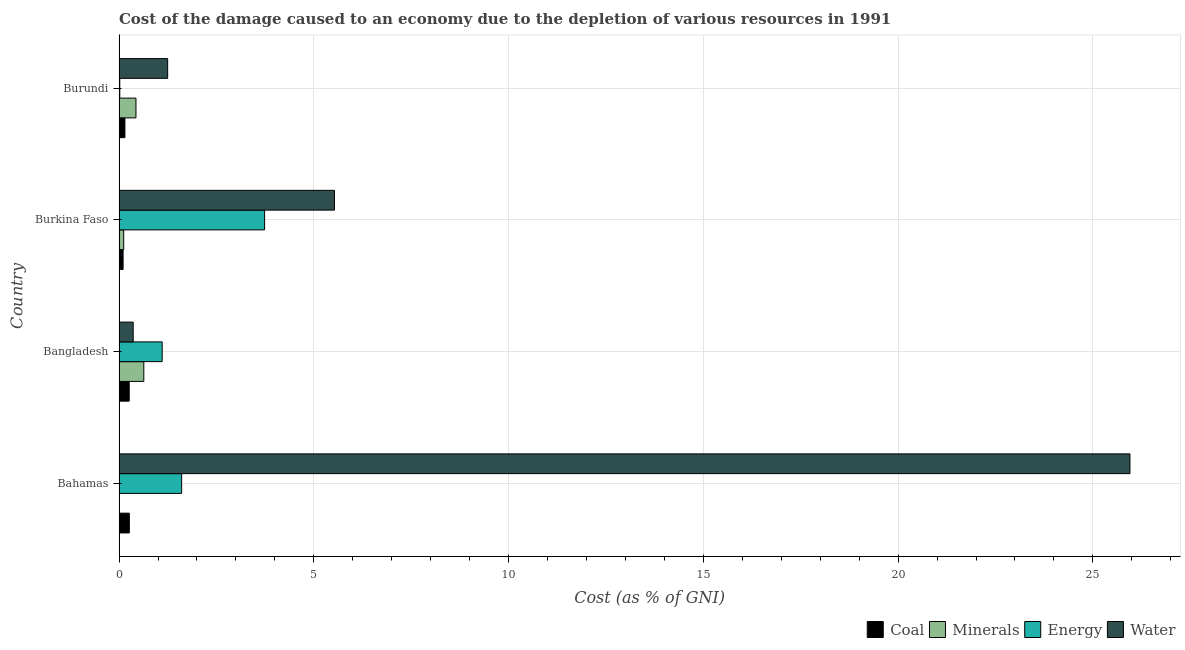How many groups of bars are there?
Your response must be concise. 4. Are the number of bars on each tick of the Y-axis equal?
Offer a very short reply. Yes. How many bars are there on the 2nd tick from the top?
Keep it short and to the point. 4. How many bars are there on the 4th tick from the bottom?
Give a very brief answer. 4. What is the label of the 4th group of bars from the top?
Your answer should be very brief. Bahamas. What is the cost of damage due to depletion of water in Bangladesh?
Offer a very short reply. 0.36. Across all countries, what is the maximum cost of damage due to depletion of minerals?
Your answer should be compact. 0.64. Across all countries, what is the minimum cost of damage due to depletion of water?
Provide a succinct answer. 0.36. In which country was the cost of damage due to depletion of energy maximum?
Your answer should be compact. Burkina Faso. In which country was the cost of damage due to depletion of minerals minimum?
Your response must be concise. Bahamas. What is the total cost of damage due to depletion of minerals in the graph?
Offer a very short reply. 1.19. What is the difference between the cost of damage due to depletion of coal in Bahamas and that in Burundi?
Ensure brevity in your answer.  0.11. What is the difference between the cost of damage due to depletion of minerals in Burkina Faso and the cost of damage due to depletion of energy in Bahamas?
Give a very brief answer. -1.49. What is the average cost of damage due to depletion of water per country?
Give a very brief answer. 8.27. What is the difference between the cost of damage due to depletion of coal and cost of damage due to depletion of minerals in Burundi?
Offer a terse response. -0.28. In how many countries, is the cost of damage due to depletion of minerals greater than 13 %?
Your response must be concise. 0. What is the ratio of the cost of damage due to depletion of water in Bahamas to that in Burkina Faso?
Make the answer very short. 4.69. Is the cost of damage due to depletion of coal in Burkina Faso less than that in Burundi?
Provide a short and direct response. Yes. What is the difference between the highest and the second highest cost of damage due to depletion of energy?
Offer a very short reply. 2.13. What is the difference between the highest and the lowest cost of damage due to depletion of energy?
Keep it short and to the point. 3.72. In how many countries, is the cost of damage due to depletion of water greater than the average cost of damage due to depletion of water taken over all countries?
Your answer should be very brief. 1. Is the sum of the cost of damage due to depletion of coal in Bahamas and Bangladesh greater than the maximum cost of damage due to depletion of water across all countries?
Give a very brief answer. No. Is it the case that in every country, the sum of the cost of damage due to depletion of energy and cost of damage due to depletion of minerals is greater than the sum of cost of damage due to depletion of water and cost of damage due to depletion of coal?
Offer a terse response. No. What does the 2nd bar from the top in Burundi represents?
Keep it short and to the point. Energy. What does the 4th bar from the bottom in Bangladesh represents?
Your response must be concise. Water. Is it the case that in every country, the sum of the cost of damage due to depletion of coal and cost of damage due to depletion of minerals is greater than the cost of damage due to depletion of energy?
Your answer should be compact. No. Are all the bars in the graph horizontal?
Provide a short and direct response. Yes. How many countries are there in the graph?
Provide a succinct answer. 4. What is the difference between two consecutive major ticks on the X-axis?
Ensure brevity in your answer.  5. What is the title of the graph?
Offer a very short reply. Cost of the damage caused to an economy due to the depletion of various resources in 1991 . What is the label or title of the X-axis?
Give a very brief answer. Cost (as % of GNI). What is the Cost (as % of GNI) in Coal in Bahamas?
Offer a terse response. 0.26. What is the Cost (as % of GNI) in Minerals in Bahamas?
Give a very brief answer. 0. What is the Cost (as % of GNI) of Energy in Bahamas?
Keep it short and to the point. 1.61. What is the Cost (as % of GNI) of Water in Bahamas?
Your answer should be very brief. 25.95. What is the Cost (as % of GNI) in Coal in Bangladesh?
Offer a terse response. 0.26. What is the Cost (as % of GNI) of Minerals in Bangladesh?
Make the answer very short. 0.64. What is the Cost (as % of GNI) of Energy in Bangladesh?
Keep it short and to the point. 1.11. What is the Cost (as % of GNI) in Water in Bangladesh?
Offer a very short reply. 0.36. What is the Cost (as % of GNI) in Coal in Burkina Faso?
Your answer should be very brief. 0.1. What is the Cost (as % of GNI) of Minerals in Burkina Faso?
Offer a terse response. 0.12. What is the Cost (as % of GNI) in Energy in Burkina Faso?
Your response must be concise. 3.74. What is the Cost (as % of GNI) of Water in Burkina Faso?
Make the answer very short. 5.53. What is the Cost (as % of GNI) in Coal in Burundi?
Provide a short and direct response. 0.15. What is the Cost (as % of GNI) in Minerals in Burundi?
Provide a short and direct response. 0.43. What is the Cost (as % of GNI) in Energy in Burundi?
Make the answer very short. 0.02. What is the Cost (as % of GNI) in Water in Burundi?
Provide a succinct answer. 1.25. Across all countries, what is the maximum Cost (as % of GNI) in Coal?
Offer a very short reply. 0.26. Across all countries, what is the maximum Cost (as % of GNI) of Minerals?
Give a very brief answer. 0.64. Across all countries, what is the maximum Cost (as % of GNI) of Energy?
Ensure brevity in your answer.  3.74. Across all countries, what is the maximum Cost (as % of GNI) of Water?
Keep it short and to the point. 25.95. Across all countries, what is the minimum Cost (as % of GNI) in Coal?
Keep it short and to the point. 0.1. Across all countries, what is the minimum Cost (as % of GNI) of Minerals?
Provide a short and direct response. 0. Across all countries, what is the minimum Cost (as % of GNI) in Energy?
Offer a terse response. 0.02. Across all countries, what is the minimum Cost (as % of GNI) in Water?
Give a very brief answer. 0.36. What is the total Cost (as % of GNI) of Coal in the graph?
Offer a terse response. 0.78. What is the total Cost (as % of GNI) in Minerals in the graph?
Make the answer very short. 1.19. What is the total Cost (as % of GNI) in Energy in the graph?
Keep it short and to the point. 6.47. What is the total Cost (as % of GNI) of Water in the graph?
Offer a terse response. 33.09. What is the difference between the Cost (as % of GNI) of Coal in Bahamas and that in Bangladesh?
Offer a terse response. 0. What is the difference between the Cost (as % of GNI) in Minerals in Bahamas and that in Bangladesh?
Provide a succinct answer. -0.63. What is the difference between the Cost (as % of GNI) in Energy in Bahamas and that in Bangladesh?
Your answer should be very brief. 0.5. What is the difference between the Cost (as % of GNI) of Water in Bahamas and that in Bangladesh?
Your answer should be compact. 25.59. What is the difference between the Cost (as % of GNI) in Coal in Bahamas and that in Burkina Faso?
Offer a terse response. 0.16. What is the difference between the Cost (as % of GNI) of Minerals in Bahamas and that in Burkina Faso?
Provide a short and direct response. -0.12. What is the difference between the Cost (as % of GNI) of Energy in Bahamas and that in Burkina Faso?
Your answer should be compact. -2.13. What is the difference between the Cost (as % of GNI) of Water in Bahamas and that in Burkina Faso?
Give a very brief answer. 20.42. What is the difference between the Cost (as % of GNI) in Coal in Bahamas and that in Burundi?
Your response must be concise. 0.11. What is the difference between the Cost (as % of GNI) of Minerals in Bahamas and that in Burundi?
Give a very brief answer. -0.43. What is the difference between the Cost (as % of GNI) in Energy in Bahamas and that in Burundi?
Give a very brief answer. 1.59. What is the difference between the Cost (as % of GNI) of Water in Bahamas and that in Burundi?
Provide a short and direct response. 24.7. What is the difference between the Cost (as % of GNI) in Coal in Bangladesh and that in Burkina Faso?
Keep it short and to the point. 0.16. What is the difference between the Cost (as % of GNI) in Minerals in Bangladesh and that in Burkina Faso?
Give a very brief answer. 0.52. What is the difference between the Cost (as % of GNI) of Energy in Bangladesh and that in Burkina Faso?
Provide a succinct answer. -2.63. What is the difference between the Cost (as % of GNI) of Water in Bangladesh and that in Burkina Faso?
Offer a terse response. -5.17. What is the difference between the Cost (as % of GNI) in Coal in Bangladesh and that in Burundi?
Your response must be concise. 0.11. What is the difference between the Cost (as % of GNI) of Minerals in Bangladesh and that in Burundi?
Keep it short and to the point. 0.2. What is the difference between the Cost (as % of GNI) in Energy in Bangladesh and that in Burundi?
Offer a terse response. 1.09. What is the difference between the Cost (as % of GNI) in Water in Bangladesh and that in Burundi?
Offer a terse response. -0.89. What is the difference between the Cost (as % of GNI) in Coal in Burkina Faso and that in Burundi?
Offer a very short reply. -0.05. What is the difference between the Cost (as % of GNI) in Minerals in Burkina Faso and that in Burundi?
Provide a succinct answer. -0.32. What is the difference between the Cost (as % of GNI) of Energy in Burkina Faso and that in Burundi?
Provide a short and direct response. 3.72. What is the difference between the Cost (as % of GNI) of Water in Burkina Faso and that in Burundi?
Your answer should be compact. 4.28. What is the difference between the Cost (as % of GNI) of Coal in Bahamas and the Cost (as % of GNI) of Minerals in Bangladesh?
Your response must be concise. -0.37. What is the difference between the Cost (as % of GNI) of Coal in Bahamas and the Cost (as % of GNI) of Energy in Bangladesh?
Offer a terse response. -0.84. What is the difference between the Cost (as % of GNI) of Coal in Bahamas and the Cost (as % of GNI) of Water in Bangladesh?
Your answer should be very brief. -0.1. What is the difference between the Cost (as % of GNI) in Minerals in Bahamas and the Cost (as % of GNI) in Energy in Bangladesh?
Provide a succinct answer. -1.1. What is the difference between the Cost (as % of GNI) in Minerals in Bahamas and the Cost (as % of GNI) in Water in Bangladesh?
Your answer should be very brief. -0.36. What is the difference between the Cost (as % of GNI) of Energy in Bahamas and the Cost (as % of GNI) of Water in Bangladesh?
Give a very brief answer. 1.24. What is the difference between the Cost (as % of GNI) in Coal in Bahamas and the Cost (as % of GNI) in Minerals in Burkina Faso?
Make the answer very short. 0.14. What is the difference between the Cost (as % of GNI) of Coal in Bahamas and the Cost (as % of GNI) of Energy in Burkina Faso?
Ensure brevity in your answer.  -3.47. What is the difference between the Cost (as % of GNI) in Coal in Bahamas and the Cost (as % of GNI) in Water in Burkina Faso?
Offer a very short reply. -5.27. What is the difference between the Cost (as % of GNI) of Minerals in Bahamas and the Cost (as % of GNI) of Energy in Burkina Faso?
Keep it short and to the point. -3.73. What is the difference between the Cost (as % of GNI) in Minerals in Bahamas and the Cost (as % of GNI) in Water in Burkina Faso?
Offer a very short reply. -5.53. What is the difference between the Cost (as % of GNI) of Energy in Bahamas and the Cost (as % of GNI) of Water in Burkina Faso?
Provide a succinct answer. -3.92. What is the difference between the Cost (as % of GNI) in Coal in Bahamas and the Cost (as % of GNI) in Minerals in Burundi?
Offer a very short reply. -0.17. What is the difference between the Cost (as % of GNI) of Coal in Bahamas and the Cost (as % of GNI) of Energy in Burundi?
Provide a succinct answer. 0.25. What is the difference between the Cost (as % of GNI) of Coal in Bahamas and the Cost (as % of GNI) of Water in Burundi?
Your answer should be compact. -0.98. What is the difference between the Cost (as % of GNI) in Minerals in Bahamas and the Cost (as % of GNI) in Energy in Burundi?
Provide a succinct answer. -0.01. What is the difference between the Cost (as % of GNI) in Minerals in Bahamas and the Cost (as % of GNI) in Water in Burundi?
Your answer should be compact. -1.24. What is the difference between the Cost (as % of GNI) of Energy in Bahamas and the Cost (as % of GNI) of Water in Burundi?
Provide a short and direct response. 0.36. What is the difference between the Cost (as % of GNI) in Coal in Bangladesh and the Cost (as % of GNI) in Minerals in Burkina Faso?
Your response must be concise. 0.14. What is the difference between the Cost (as % of GNI) in Coal in Bangladesh and the Cost (as % of GNI) in Energy in Burkina Faso?
Your answer should be compact. -3.48. What is the difference between the Cost (as % of GNI) of Coal in Bangladesh and the Cost (as % of GNI) of Water in Burkina Faso?
Your response must be concise. -5.27. What is the difference between the Cost (as % of GNI) in Minerals in Bangladesh and the Cost (as % of GNI) in Energy in Burkina Faso?
Offer a terse response. -3.1. What is the difference between the Cost (as % of GNI) in Minerals in Bangladesh and the Cost (as % of GNI) in Water in Burkina Faso?
Your answer should be very brief. -4.89. What is the difference between the Cost (as % of GNI) in Energy in Bangladesh and the Cost (as % of GNI) in Water in Burkina Faso?
Offer a very short reply. -4.42. What is the difference between the Cost (as % of GNI) of Coal in Bangladesh and the Cost (as % of GNI) of Minerals in Burundi?
Ensure brevity in your answer.  -0.17. What is the difference between the Cost (as % of GNI) of Coal in Bangladesh and the Cost (as % of GNI) of Energy in Burundi?
Offer a terse response. 0.24. What is the difference between the Cost (as % of GNI) in Coal in Bangladesh and the Cost (as % of GNI) in Water in Burundi?
Provide a succinct answer. -0.99. What is the difference between the Cost (as % of GNI) of Minerals in Bangladesh and the Cost (as % of GNI) of Energy in Burundi?
Provide a succinct answer. 0.62. What is the difference between the Cost (as % of GNI) in Minerals in Bangladesh and the Cost (as % of GNI) in Water in Burundi?
Offer a very short reply. -0.61. What is the difference between the Cost (as % of GNI) of Energy in Bangladesh and the Cost (as % of GNI) of Water in Burundi?
Give a very brief answer. -0.14. What is the difference between the Cost (as % of GNI) of Coal in Burkina Faso and the Cost (as % of GNI) of Minerals in Burundi?
Give a very brief answer. -0.33. What is the difference between the Cost (as % of GNI) in Coal in Burkina Faso and the Cost (as % of GNI) in Energy in Burundi?
Offer a terse response. 0.08. What is the difference between the Cost (as % of GNI) of Coal in Burkina Faso and the Cost (as % of GNI) of Water in Burundi?
Keep it short and to the point. -1.14. What is the difference between the Cost (as % of GNI) of Minerals in Burkina Faso and the Cost (as % of GNI) of Energy in Burundi?
Offer a terse response. 0.1. What is the difference between the Cost (as % of GNI) of Minerals in Burkina Faso and the Cost (as % of GNI) of Water in Burundi?
Offer a very short reply. -1.13. What is the difference between the Cost (as % of GNI) in Energy in Burkina Faso and the Cost (as % of GNI) in Water in Burundi?
Keep it short and to the point. 2.49. What is the average Cost (as % of GNI) of Coal per country?
Keep it short and to the point. 0.19. What is the average Cost (as % of GNI) in Minerals per country?
Your response must be concise. 0.3. What is the average Cost (as % of GNI) in Energy per country?
Your answer should be compact. 1.62. What is the average Cost (as % of GNI) in Water per country?
Provide a short and direct response. 8.27. What is the difference between the Cost (as % of GNI) in Coal and Cost (as % of GNI) in Minerals in Bahamas?
Your response must be concise. 0.26. What is the difference between the Cost (as % of GNI) of Coal and Cost (as % of GNI) of Energy in Bahamas?
Ensure brevity in your answer.  -1.34. What is the difference between the Cost (as % of GNI) in Coal and Cost (as % of GNI) in Water in Bahamas?
Offer a terse response. -25.69. What is the difference between the Cost (as % of GNI) of Minerals and Cost (as % of GNI) of Energy in Bahamas?
Give a very brief answer. -1.6. What is the difference between the Cost (as % of GNI) of Minerals and Cost (as % of GNI) of Water in Bahamas?
Provide a succinct answer. -25.95. What is the difference between the Cost (as % of GNI) in Energy and Cost (as % of GNI) in Water in Bahamas?
Offer a terse response. -24.34. What is the difference between the Cost (as % of GNI) in Coal and Cost (as % of GNI) in Minerals in Bangladesh?
Keep it short and to the point. -0.38. What is the difference between the Cost (as % of GNI) of Coal and Cost (as % of GNI) of Energy in Bangladesh?
Ensure brevity in your answer.  -0.85. What is the difference between the Cost (as % of GNI) of Coal and Cost (as % of GNI) of Water in Bangladesh?
Give a very brief answer. -0.1. What is the difference between the Cost (as % of GNI) in Minerals and Cost (as % of GNI) in Energy in Bangladesh?
Keep it short and to the point. -0.47. What is the difference between the Cost (as % of GNI) in Minerals and Cost (as % of GNI) in Water in Bangladesh?
Provide a succinct answer. 0.27. What is the difference between the Cost (as % of GNI) of Energy and Cost (as % of GNI) of Water in Bangladesh?
Make the answer very short. 0.74. What is the difference between the Cost (as % of GNI) in Coal and Cost (as % of GNI) in Minerals in Burkina Faso?
Offer a terse response. -0.02. What is the difference between the Cost (as % of GNI) of Coal and Cost (as % of GNI) of Energy in Burkina Faso?
Your answer should be compact. -3.63. What is the difference between the Cost (as % of GNI) of Coal and Cost (as % of GNI) of Water in Burkina Faso?
Provide a succinct answer. -5.43. What is the difference between the Cost (as % of GNI) in Minerals and Cost (as % of GNI) in Energy in Burkina Faso?
Your answer should be compact. -3.62. What is the difference between the Cost (as % of GNI) of Minerals and Cost (as % of GNI) of Water in Burkina Faso?
Give a very brief answer. -5.41. What is the difference between the Cost (as % of GNI) of Energy and Cost (as % of GNI) of Water in Burkina Faso?
Make the answer very short. -1.79. What is the difference between the Cost (as % of GNI) in Coal and Cost (as % of GNI) in Minerals in Burundi?
Provide a succinct answer. -0.28. What is the difference between the Cost (as % of GNI) in Coal and Cost (as % of GNI) in Energy in Burundi?
Offer a terse response. 0.13. What is the difference between the Cost (as % of GNI) in Coal and Cost (as % of GNI) in Water in Burundi?
Offer a very short reply. -1.1. What is the difference between the Cost (as % of GNI) of Minerals and Cost (as % of GNI) of Energy in Burundi?
Make the answer very short. 0.42. What is the difference between the Cost (as % of GNI) of Minerals and Cost (as % of GNI) of Water in Burundi?
Provide a succinct answer. -0.81. What is the difference between the Cost (as % of GNI) in Energy and Cost (as % of GNI) in Water in Burundi?
Your answer should be very brief. -1.23. What is the ratio of the Cost (as % of GNI) of Coal in Bahamas to that in Bangladesh?
Your response must be concise. 1.01. What is the ratio of the Cost (as % of GNI) in Minerals in Bahamas to that in Bangladesh?
Your answer should be compact. 0.01. What is the ratio of the Cost (as % of GNI) of Energy in Bahamas to that in Bangladesh?
Ensure brevity in your answer.  1.45. What is the ratio of the Cost (as % of GNI) of Water in Bahamas to that in Bangladesh?
Provide a succinct answer. 71.55. What is the ratio of the Cost (as % of GNI) in Coal in Bahamas to that in Burkina Faso?
Make the answer very short. 2.55. What is the ratio of the Cost (as % of GNI) of Minerals in Bahamas to that in Burkina Faso?
Offer a very short reply. 0.04. What is the ratio of the Cost (as % of GNI) of Energy in Bahamas to that in Burkina Faso?
Your answer should be very brief. 0.43. What is the ratio of the Cost (as % of GNI) in Water in Bahamas to that in Burkina Faso?
Provide a short and direct response. 4.69. What is the ratio of the Cost (as % of GNI) in Coal in Bahamas to that in Burundi?
Provide a short and direct response. 1.75. What is the ratio of the Cost (as % of GNI) in Minerals in Bahamas to that in Burundi?
Ensure brevity in your answer.  0.01. What is the ratio of the Cost (as % of GNI) in Energy in Bahamas to that in Burundi?
Provide a short and direct response. 85.35. What is the ratio of the Cost (as % of GNI) in Water in Bahamas to that in Burundi?
Give a very brief answer. 20.8. What is the ratio of the Cost (as % of GNI) in Coal in Bangladesh to that in Burkina Faso?
Offer a very short reply. 2.51. What is the ratio of the Cost (as % of GNI) in Minerals in Bangladesh to that in Burkina Faso?
Your answer should be very brief. 5.32. What is the ratio of the Cost (as % of GNI) of Energy in Bangladesh to that in Burkina Faso?
Provide a short and direct response. 0.3. What is the ratio of the Cost (as % of GNI) in Water in Bangladesh to that in Burkina Faso?
Ensure brevity in your answer.  0.07. What is the ratio of the Cost (as % of GNI) of Coal in Bangladesh to that in Burundi?
Keep it short and to the point. 1.73. What is the ratio of the Cost (as % of GNI) of Minerals in Bangladesh to that in Burundi?
Your answer should be compact. 1.46. What is the ratio of the Cost (as % of GNI) of Energy in Bangladesh to that in Burundi?
Keep it short and to the point. 58.83. What is the ratio of the Cost (as % of GNI) of Water in Bangladesh to that in Burundi?
Offer a terse response. 0.29. What is the ratio of the Cost (as % of GNI) in Coal in Burkina Faso to that in Burundi?
Ensure brevity in your answer.  0.69. What is the ratio of the Cost (as % of GNI) in Minerals in Burkina Faso to that in Burundi?
Ensure brevity in your answer.  0.28. What is the ratio of the Cost (as % of GNI) in Energy in Burkina Faso to that in Burundi?
Provide a succinct answer. 198.55. What is the ratio of the Cost (as % of GNI) in Water in Burkina Faso to that in Burundi?
Your response must be concise. 4.43. What is the difference between the highest and the second highest Cost (as % of GNI) of Coal?
Give a very brief answer. 0. What is the difference between the highest and the second highest Cost (as % of GNI) in Minerals?
Your response must be concise. 0.2. What is the difference between the highest and the second highest Cost (as % of GNI) of Energy?
Provide a succinct answer. 2.13. What is the difference between the highest and the second highest Cost (as % of GNI) in Water?
Provide a short and direct response. 20.42. What is the difference between the highest and the lowest Cost (as % of GNI) of Coal?
Give a very brief answer. 0.16. What is the difference between the highest and the lowest Cost (as % of GNI) of Minerals?
Ensure brevity in your answer.  0.63. What is the difference between the highest and the lowest Cost (as % of GNI) in Energy?
Make the answer very short. 3.72. What is the difference between the highest and the lowest Cost (as % of GNI) of Water?
Provide a short and direct response. 25.59. 